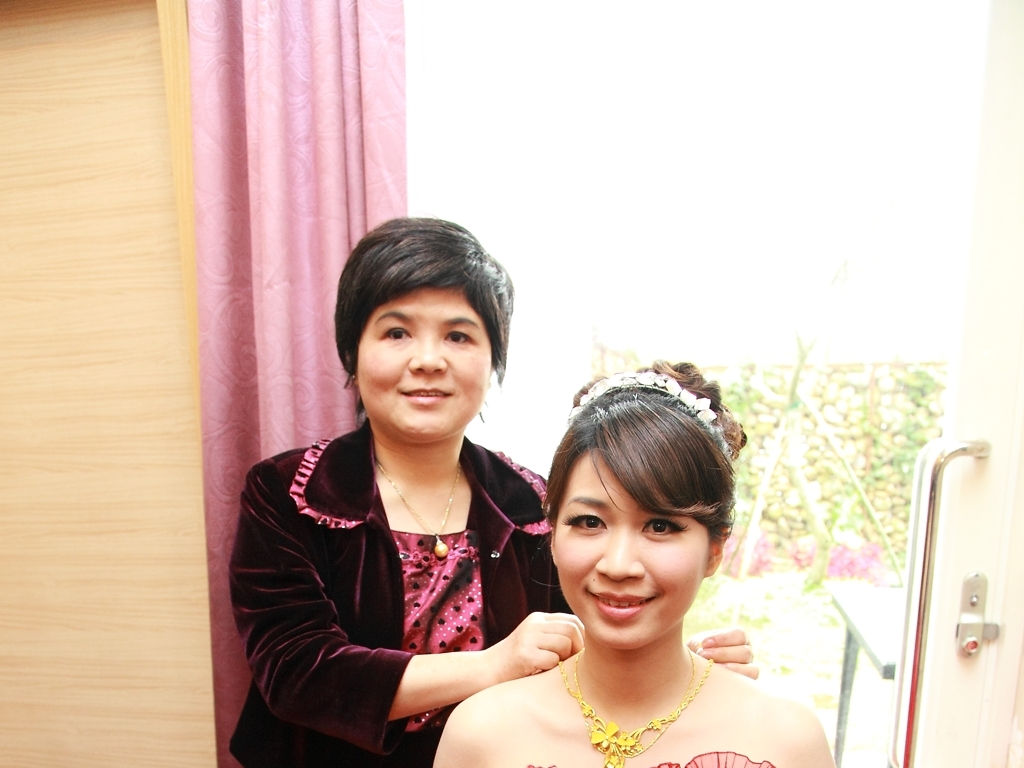What details in their clothing and accessories stand out to you? The woman on the right has a very ornate appearance, wearing a dress adorned with a floral design and a striking golden necklace. Her hair is styled with a decorative hairpiece, adding to the formal look. The woman on the left is dressed more casually in a velvet top, which contrasts with the formality of the other individual's attire. 